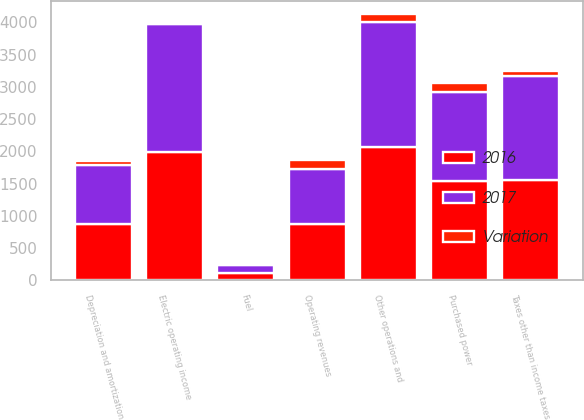<chart> <loc_0><loc_0><loc_500><loc_500><stacked_bar_chart><ecel><fcel>Operating revenues<fcel>Purchased power<fcel>Fuel<fcel>Other operations and<fcel>Depreciation and amortization<fcel>Taxes other than income taxes<fcel>Electric operating income<nl><fcel>2017<fcel>865<fcel>1379<fcel>127<fcel>1942<fcel>925<fcel>1625<fcel>1974<nl><fcel>2016<fcel>865<fcel>1533<fcel>104<fcel>2061<fcel>865<fcel>1547<fcel>1996<nl><fcel>Variation<fcel>134<fcel>154<fcel>23<fcel>119<fcel>60<fcel>78<fcel>22<nl></chart> 